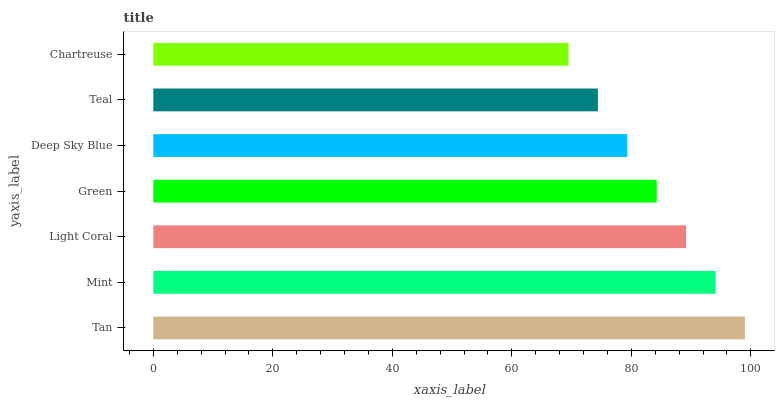Is Chartreuse the minimum?
Answer yes or no. Yes. Is Tan the maximum?
Answer yes or no. Yes. Is Mint the minimum?
Answer yes or no. No. Is Mint the maximum?
Answer yes or no. No. Is Tan greater than Mint?
Answer yes or no. Yes. Is Mint less than Tan?
Answer yes or no. Yes. Is Mint greater than Tan?
Answer yes or no. No. Is Tan less than Mint?
Answer yes or no. No. Is Green the high median?
Answer yes or no. Yes. Is Green the low median?
Answer yes or no. Yes. Is Deep Sky Blue the high median?
Answer yes or no. No. Is Light Coral the low median?
Answer yes or no. No. 